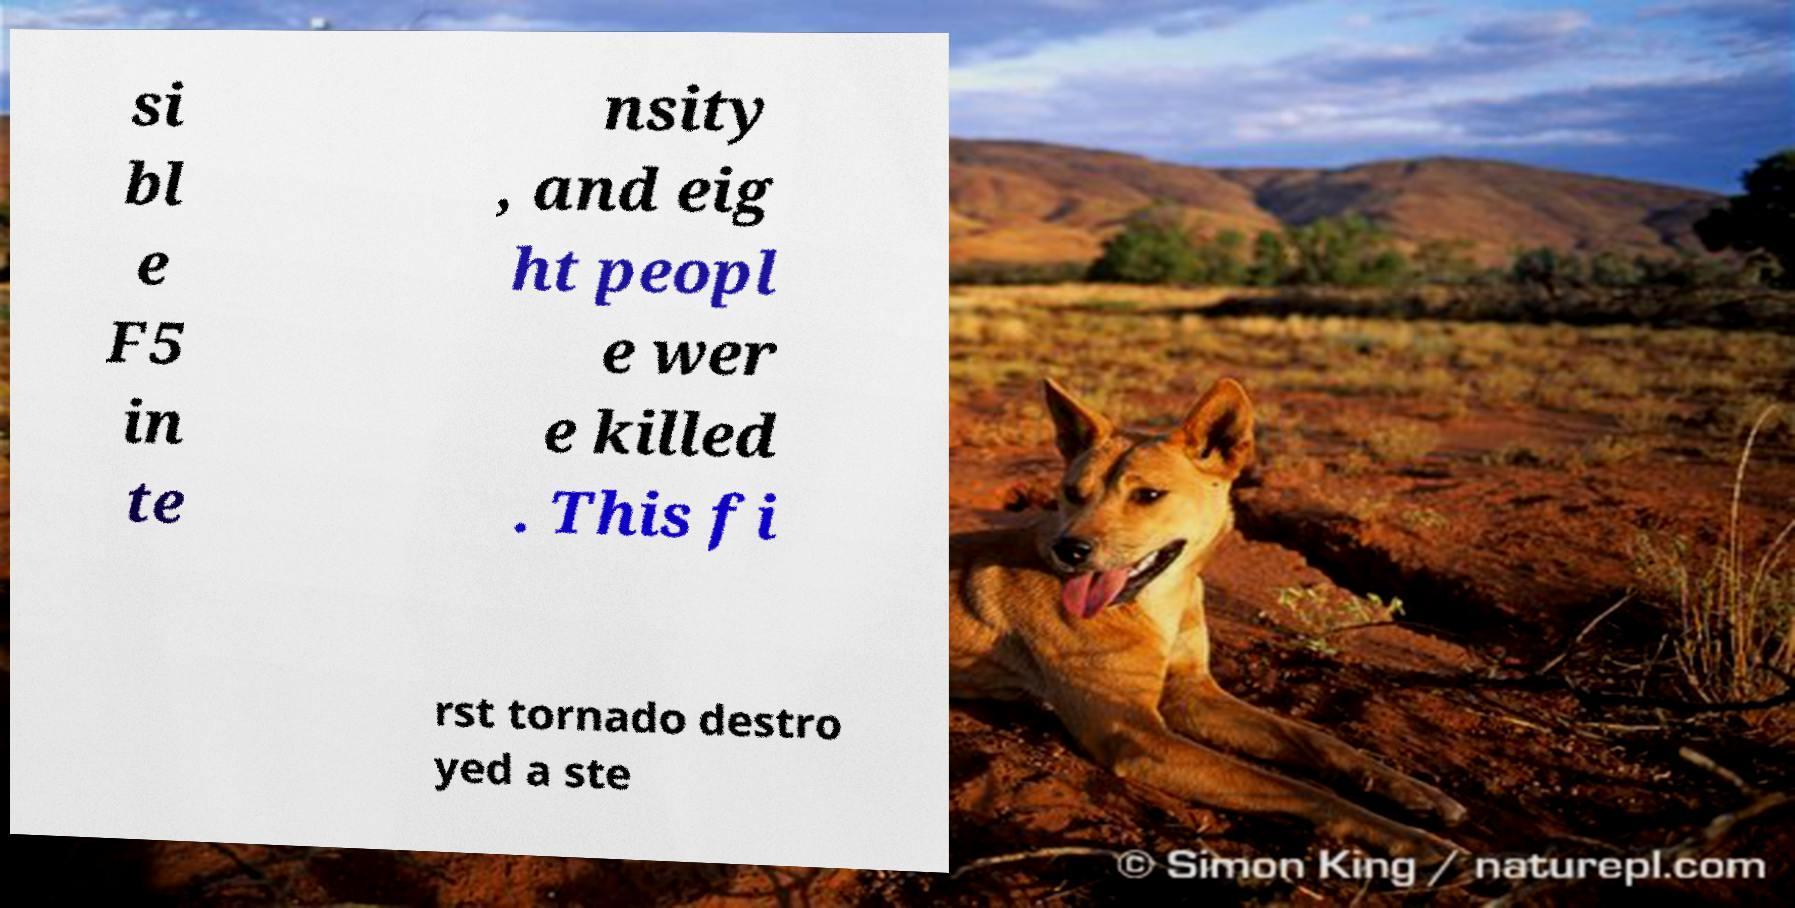What messages or text are displayed in this image? I need them in a readable, typed format. si bl e F5 in te nsity , and eig ht peopl e wer e killed . This fi rst tornado destro yed a ste 